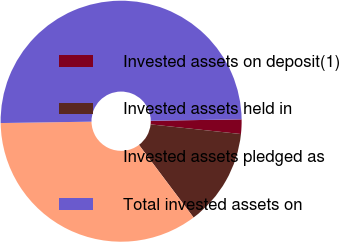Convert chart to OTSL. <chart><loc_0><loc_0><loc_500><loc_500><pie_chart><fcel>Invested assets on deposit(1)<fcel>Invested assets held in<fcel>Invested assets pledged as<fcel>Total invested assets on<nl><fcel>1.94%<fcel>13.04%<fcel>35.02%<fcel>50.0%<nl></chart> 